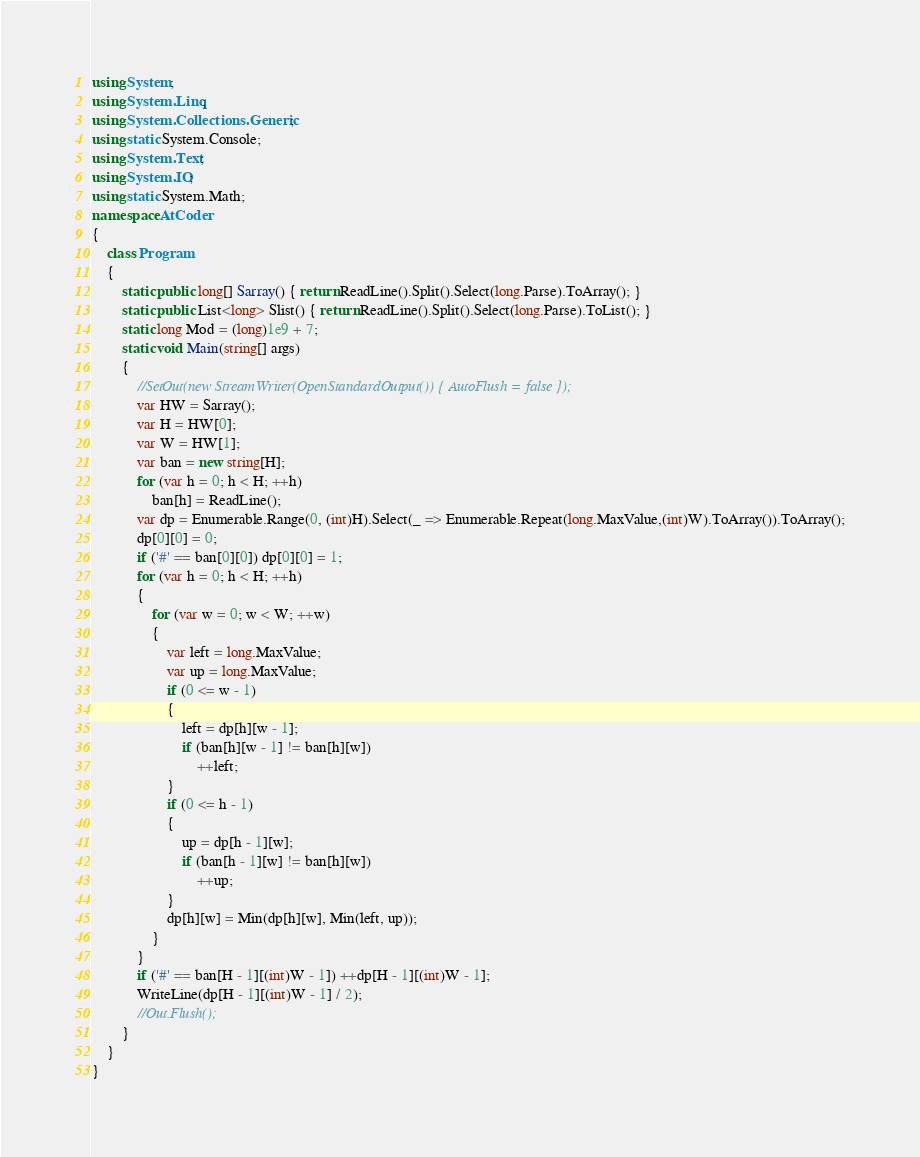Convert code to text. <code><loc_0><loc_0><loc_500><loc_500><_C#_>using System;
using System.Linq;
using System.Collections.Generic;
using static System.Console;
using System.Text;
using System.IO;
using static System.Math;
namespace AtCoder
{
    class Program
    {
        static public long[] Sarray() { return ReadLine().Split().Select(long.Parse).ToArray(); }
        static public List<long> Slist() { return ReadLine().Split().Select(long.Parse).ToList(); }
        static long Mod = (long)1e9 + 7;
        static void Main(string[] args)
        {
            //SetOut(new StreamWriter(OpenStandardOutput()) { AutoFlush = false });
            var HW = Sarray();
            var H = HW[0];
            var W = HW[1];
            var ban = new string[H];
            for (var h = 0; h < H; ++h)
                ban[h] = ReadLine();
            var dp = Enumerable.Range(0, (int)H).Select(_ => Enumerable.Repeat(long.MaxValue,(int)W).ToArray()).ToArray();
            dp[0][0] = 0;
            if ('#' == ban[0][0]) dp[0][0] = 1;
            for (var h = 0; h < H; ++h)
            {
                for (var w = 0; w < W; ++w)
                {
                    var left = long.MaxValue;
                    var up = long.MaxValue;
                    if (0 <= w - 1)
                    {
                        left = dp[h][w - 1];
                        if (ban[h][w - 1] != ban[h][w])
                            ++left;
                    }
                    if (0 <= h - 1)
                    {
                        up = dp[h - 1][w];
                        if (ban[h - 1][w] != ban[h][w])
                            ++up;
                    }
                    dp[h][w] = Min(dp[h][w], Min(left, up));
                }
            }
            if ('#' == ban[H - 1][(int)W - 1]) ++dp[H - 1][(int)W - 1];
            WriteLine(dp[H - 1][(int)W - 1] / 2);
            //Out.Flush();
        }
    }
}</code> 